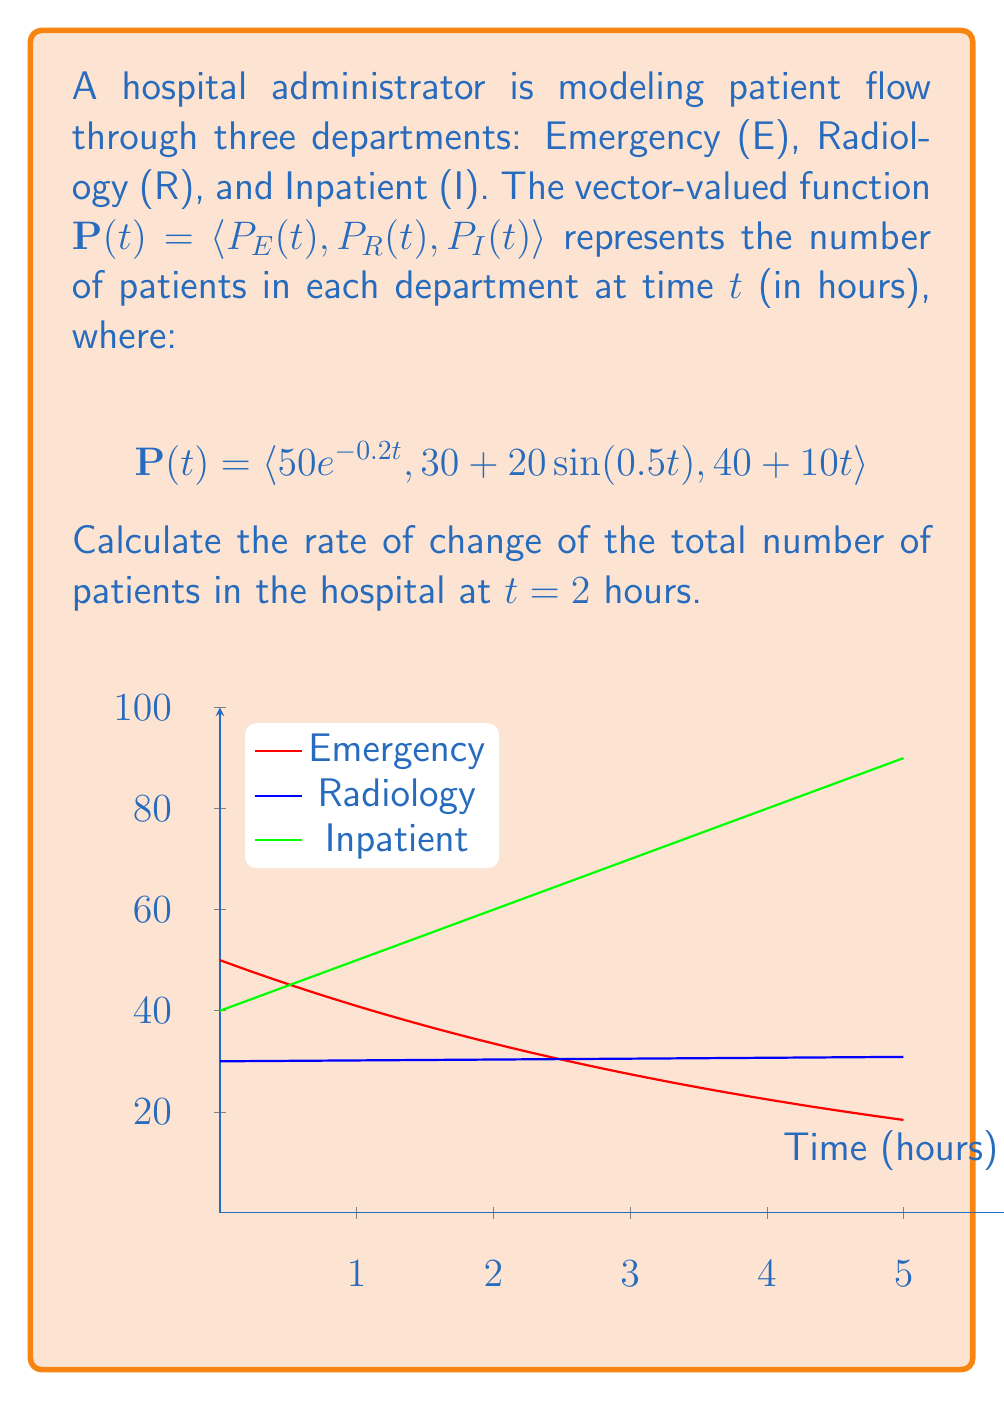Solve this math problem. To solve this problem, we need to follow these steps:

1) The total number of patients is the sum of patients in all departments:
   $T(t) = P_E(t) + P_R(t) + P_I(t)$

2) The rate of change of the total number of patients is the derivative of $T(t)$:
   $\frac{dT}{dt} = \frac{dP_E}{dt} + \frac{dP_R}{dt} + \frac{dP_I}{dt}$

3) Let's calculate each derivative:

   a) $\frac{dP_E}{dt} = -10e^{-0.2t}$
   b) $\frac{dP_R}{dt} = 10\cos(0.5t)$
   c) $\frac{dP_I}{dt} = 10$

4) Now, we substitute $t = 2$ into each derivative:

   a) $\frac{dP_E}{dt}(2) = -10e^{-0.4} \approx -6.703$
   b) $\frac{dP_R}{dt}(2) = 10\cos(1) \approx 5.403$
   c) $\frac{dP_I}{dt}(2) = 10$

5) The total rate of change at $t = 2$ is the sum of these values:

   $\frac{dT}{dt}(2) = -6.703 + 5.403 + 10 \approx 8.700$

Therefore, the rate of change of the total number of patients at $t = 2$ hours is approximately 8.700 patients per hour.
Answer: $\frac{dT}{dt}(2) \approx 8.700$ patients/hour 